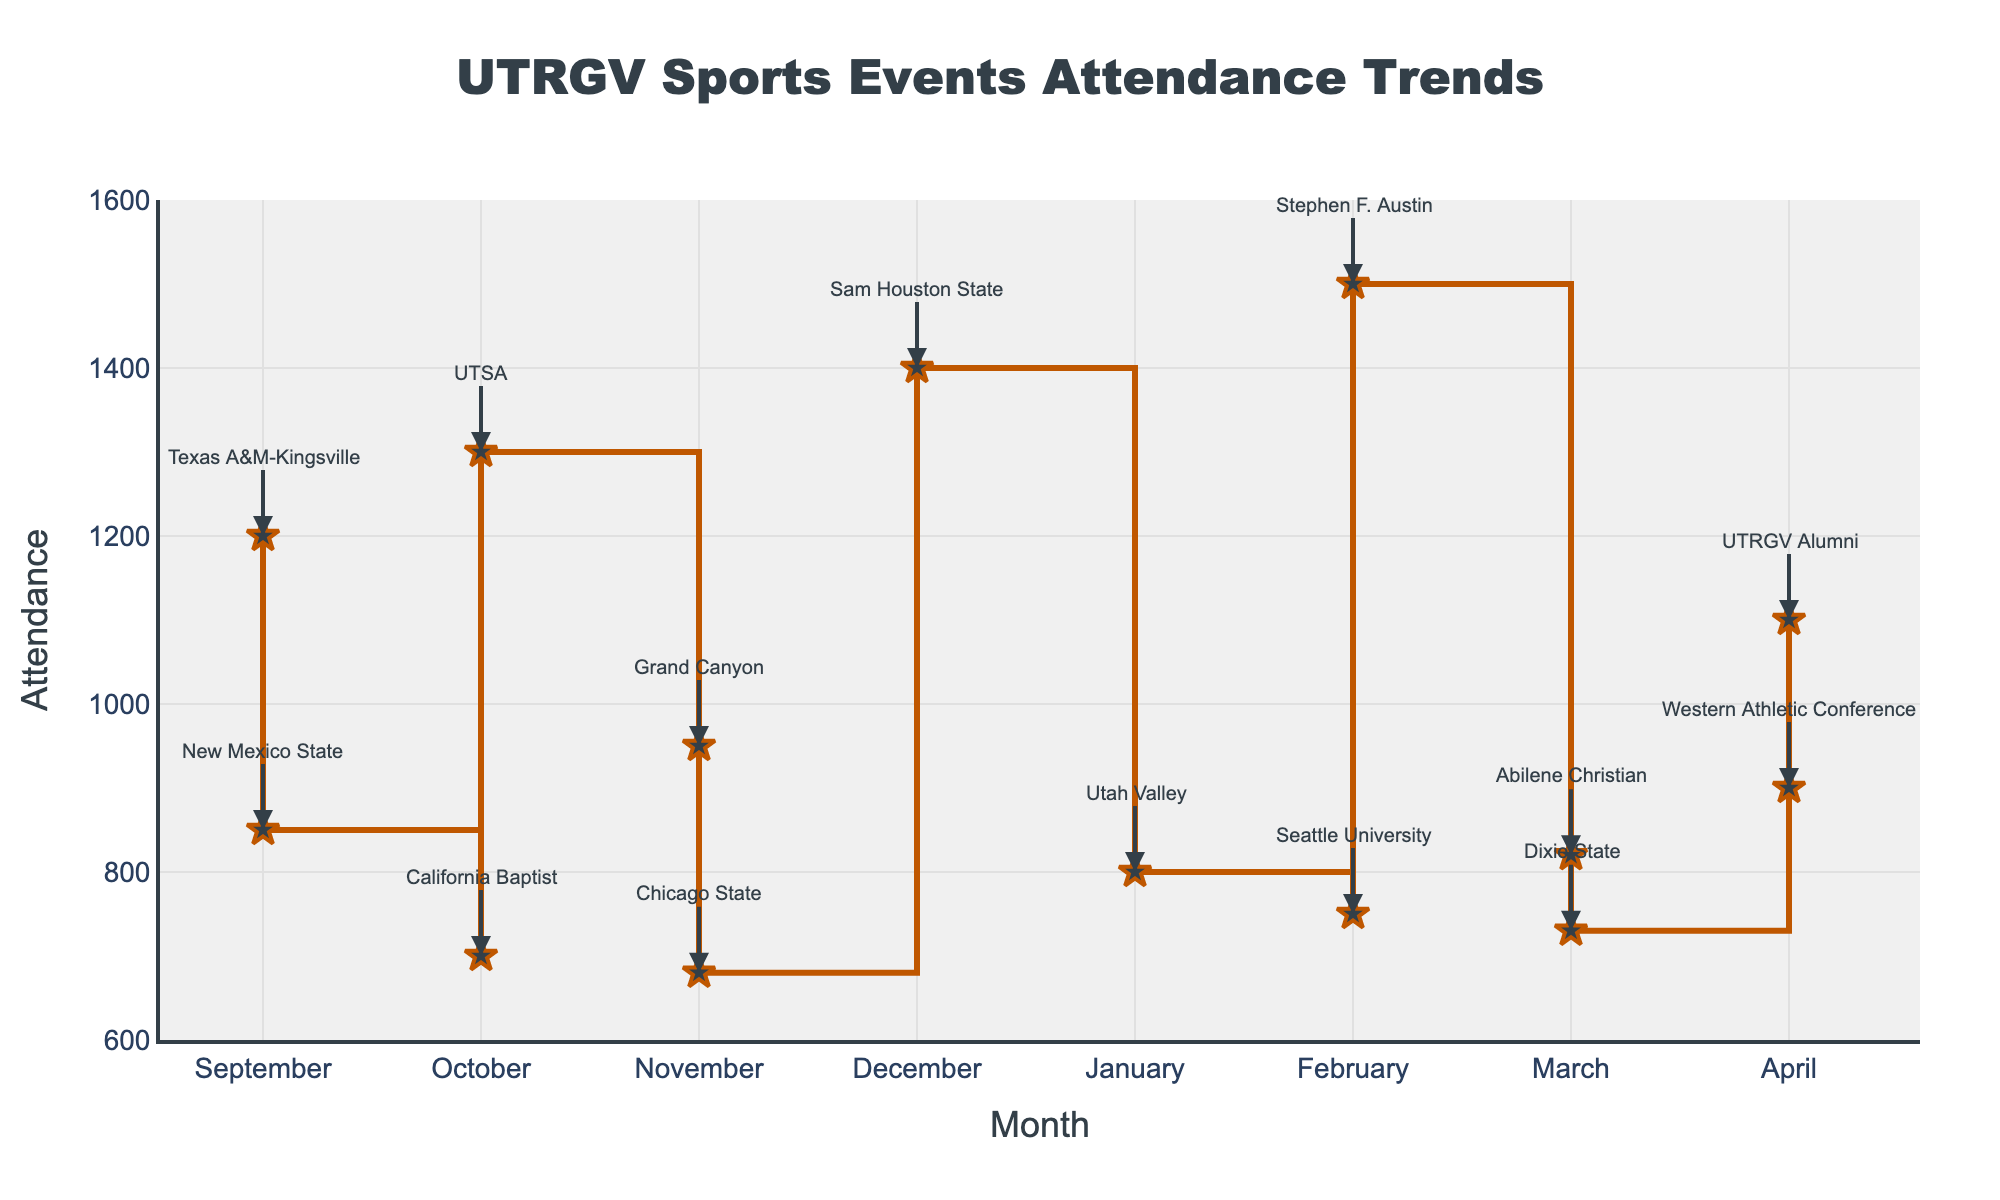What's the title of the figure? The title can be observed at the top center of the plot in large bold text.
Answer: UTRGV Sports Events Attendance Trends What's the attendance in December? Look at the point corresponding to December on the x-axis and read its value on the y-axis.
Answer: 1400 What was the attendance trend from January to March? Inspect the attendance values for January, February, and March by identifying their respective points on the plot and observing changes.
Answer: Increase then decrease What was the highest attendance recorded, and in which month? Identify the highest point on the y-axis and see which month it corresponds to on the x-axis.
Answer: 1500 in February Which month saw the lowest attendance, and what was the event? Find the lowest point on the y-axis, trace it to the corresponding month on the x-axis, and identify the event via annotations.
Answer: November, Soccer Match vs. Chicago State What was the total attendance for all basketball games? Identify each basketball game from the annotations, sum up their respective attendance figures. Basketball games occur in September, October, December, February, and April. Adding up these values: (1200 + 1300 + 1400 + 1500 + 1100).
Answer: 6500 Compare the attendance of volleyball games in September and November. Locate the points for volleyball games in September and November and compare their attendance values.
Answer: September (850) was lower than November (950) How does the attendance in November compare to that in February? Identify the attendance values in November and February and compare them.
Answer: February has higher attendance Which sport had the most variance in attendance throughout the academic year? Identify the attendance values for each sport (basketball, volleyball, soccer) and calculate their variance. Basketball seems to have the highest variance due to the wide range of values from 1100 to 1500.
Answer: Basketball 